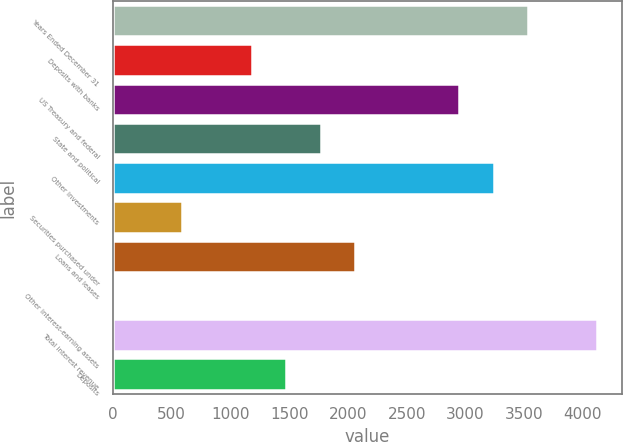Convert chart. <chart><loc_0><loc_0><loc_500><loc_500><bar_chart><fcel>Years Ended December 31<fcel>Deposits with banks<fcel>US Treasury and federal<fcel>State and political<fcel>Other investments<fcel>Securities purchased under<fcel>Loans and leases<fcel>Other interest-earning assets<fcel>Total interest revenue<fcel>Deposits<nl><fcel>3534.8<fcel>1179.6<fcel>2946<fcel>1768.4<fcel>3240.4<fcel>590.8<fcel>2062.8<fcel>2<fcel>4123.6<fcel>1474<nl></chart> 